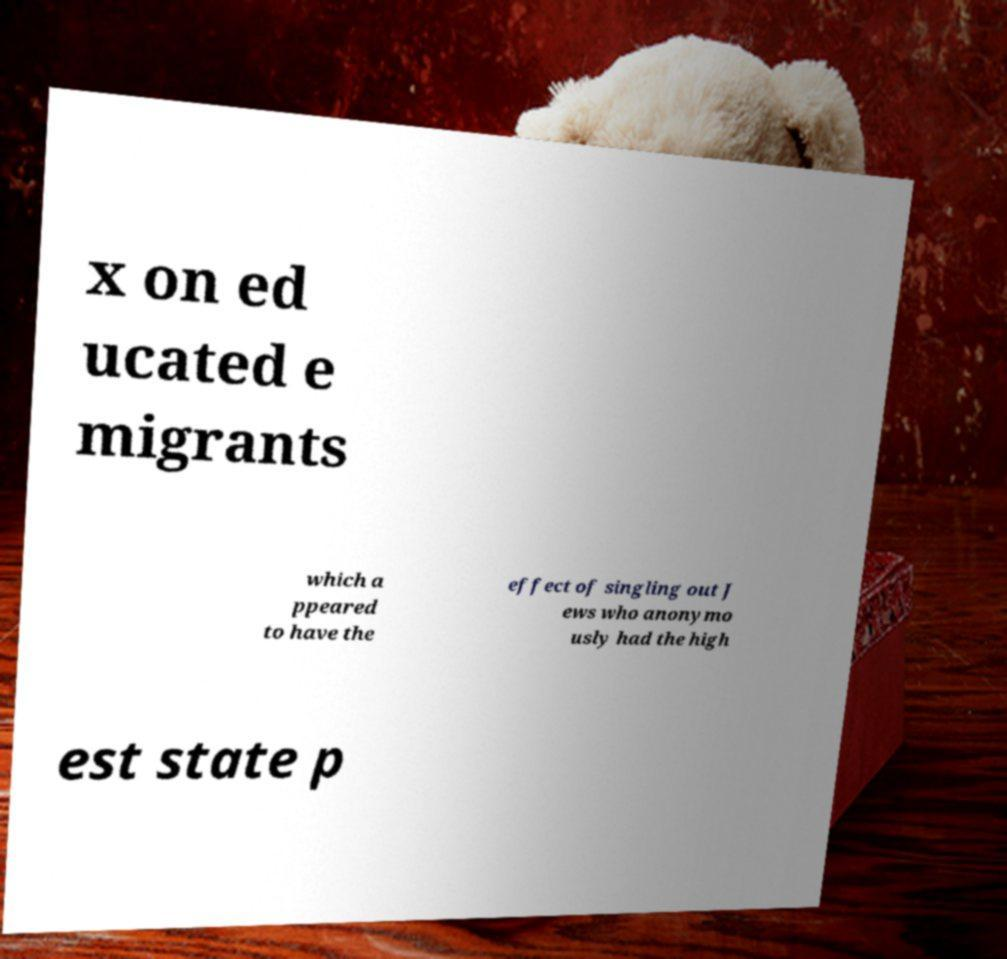Can you read and provide the text displayed in the image?This photo seems to have some interesting text. Can you extract and type it out for me? x on ed ucated e migrants which a ppeared to have the effect of singling out J ews who anonymo usly had the high est state p 